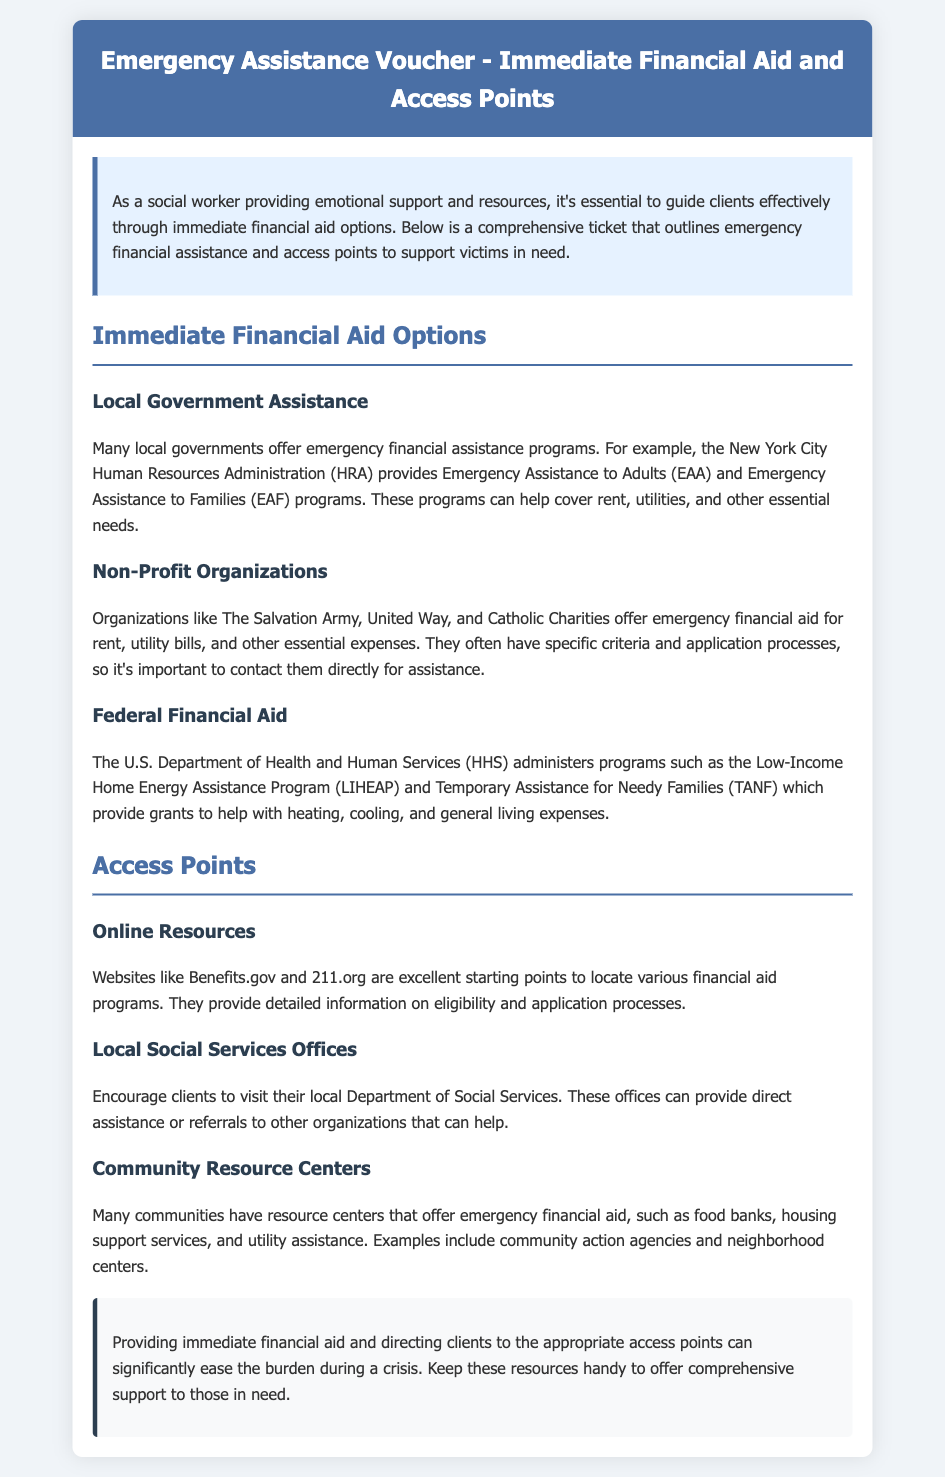What is the title of the document? The title of the document is mentioned in the header section, which describes the content of the document.
Answer: Emergency Assistance Voucher - Immediate Financial Aid and Access Points What does HRA stand for? HRA is mentioned in relation to the New York City Human Resources Administration, which provides programs for emergency assistance.
Answer: Human Resources Administration What kind of assistance does LIHEAP provide? LIHEAP is indicated as a program aimed at helping with heating, cooling, and general living expenses.
Answer: Heating, cooling, and general living expenses Which organization offers emergency financial aid for rent? The document lists several organizations that provide assistance; one prominent example is mentioned.
Answer: The Salvation Army How many types of immediate financial aid options are listed? The document outlines three distinct categories of immediate financial aid options for clients seeking help.
Answer: Three What is a recommended online resource for financial aid? The document lists websites where individuals can find financial assistance; one is specifically highlighted as beneficial.
Answer: Benefits.gov What type of agency is suggested for direct assistance? The document mentions a specific government office known for providing direct support and referrals related to social services.
Answer: Department of Social Services Which community resource center type helps with utility assistance? The document provides examples of centers that address specific urgent financial requirements, including utilities.
Answer: Community action agencies 